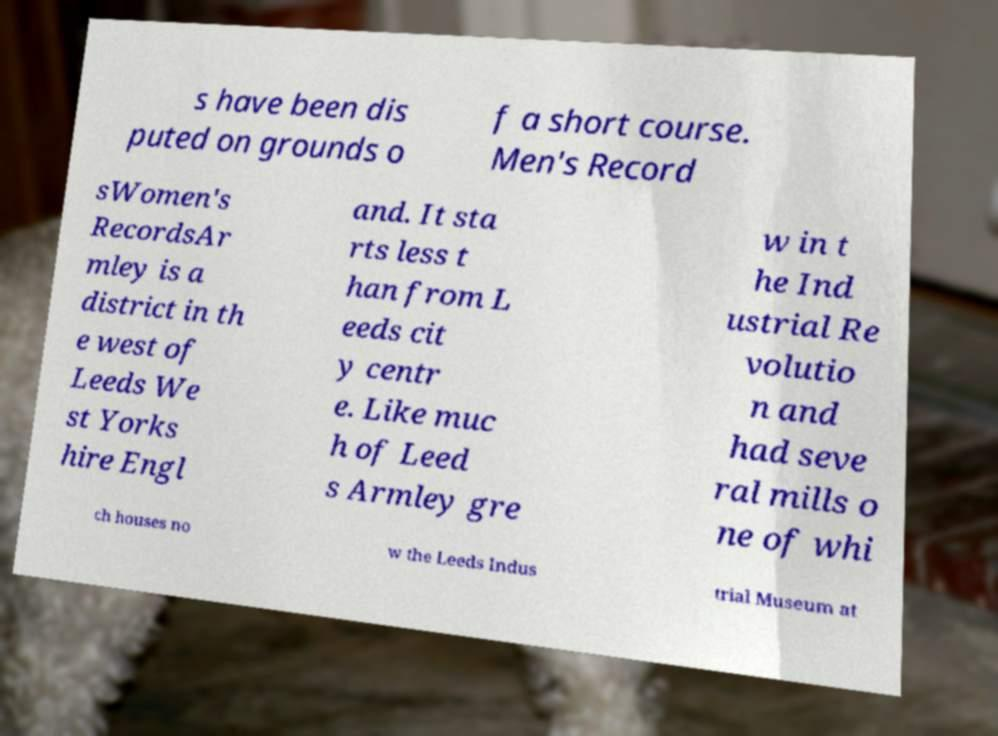Could you assist in decoding the text presented in this image and type it out clearly? s have been dis puted on grounds o f a short course. Men's Record sWomen's RecordsAr mley is a district in th e west of Leeds We st Yorks hire Engl and. It sta rts less t han from L eeds cit y centr e. Like muc h of Leed s Armley gre w in t he Ind ustrial Re volutio n and had seve ral mills o ne of whi ch houses no w the Leeds Indus trial Museum at 